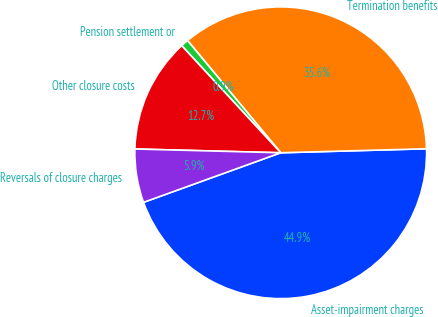Convert chart. <chart><loc_0><loc_0><loc_500><loc_500><pie_chart><fcel>Asset-impairment charges<fcel>Termination benefits<fcel>Pension settlement or<fcel>Other closure costs<fcel>Reversals of closure charges<nl><fcel>44.92%<fcel>35.59%<fcel>0.85%<fcel>12.71%<fcel>5.93%<nl></chart> 